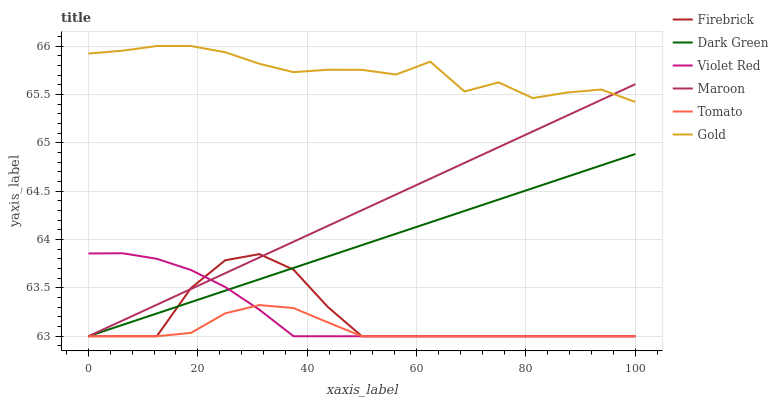Does Tomato have the minimum area under the curve?
Answer yes or no. Yes. Does Gold have the maximum area under the curve?
Answer yes or no. Yes. Does Violet Red have the minimum area under the curve?
Answer yes or no. No. Does Violet Red have the maximum area under the curve?
Answer yes or no. No. Is Maroon the smoothest?
Answer yes or no. Yes. Is Gold the roughest?
Answer yes or no. Yes. Is Violet Red the smoothest?
Answer yes or no. No. Is Violet Red the roughest?
Answer yes or no. No. Does Tomato have the lowest value?
Answer yes or no. Yes. Does Gold have the lowest value?
Answer yes or no. No. Does Gold have the highest value?
Answer yes or no. Yes. Does Violet Red have the highest value?
Answer yes or no. No. Is Dark Green less than Gold?
Answer yes or no. Yes. Is Gold greater than Tomato?
Answer yes or no. Yes. Does Maroon intersect Violet Red?
Answer yes or no. Yes. Is Maroon less than Violet Red?
Answer yes or no. No. Is Maroon greater than Violet Red?
Answer yes or no. No. Does Dark Green intersect Gold?
Answer yes or no. No. 